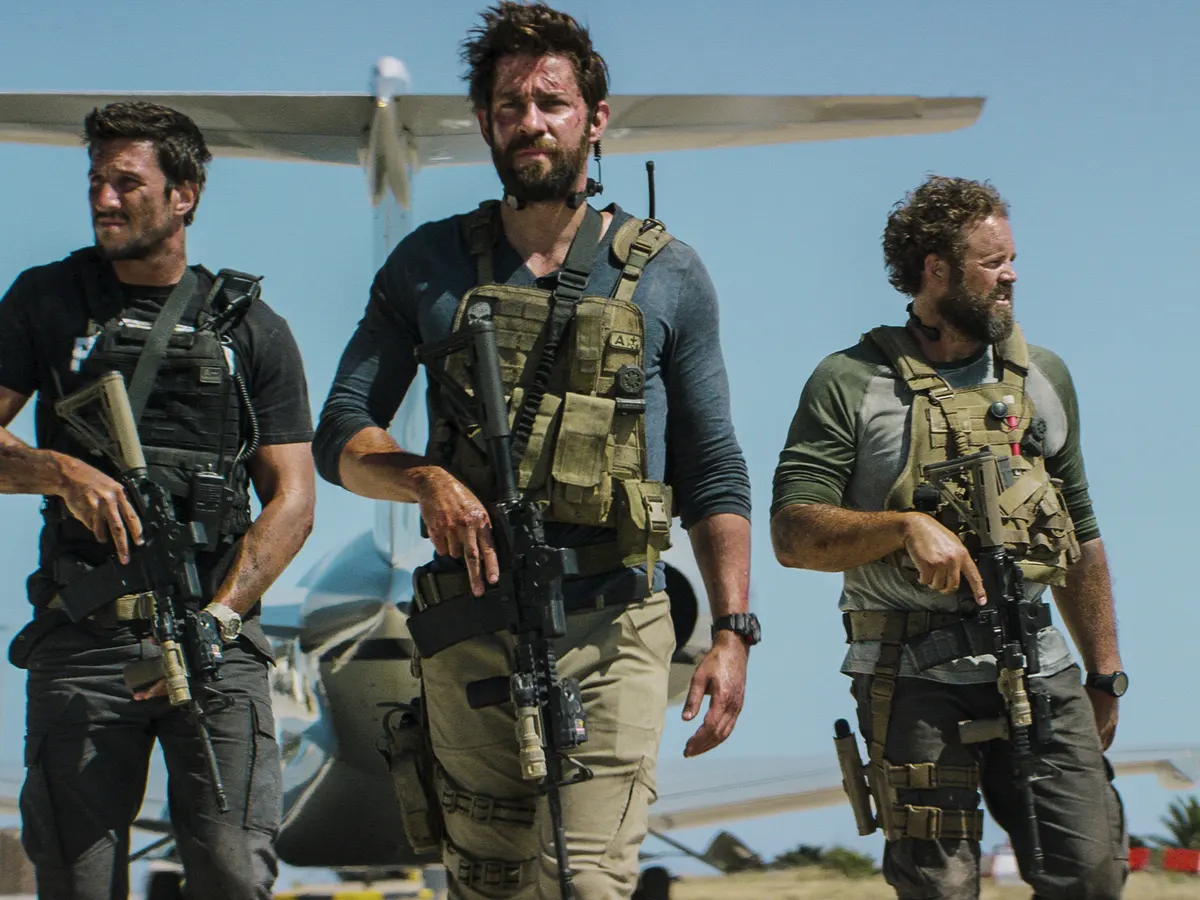Can you describe the interplay of emotions and body language exhibited by the individuals? Certainly. The central figure seems to embody leadership, with forward momentum and an unwavering gaze. The two flanking him reflect solidarity, with their postures mirroring his determination. This cohesive body language conveys a shared resolve, likely indicative of their training and the gravity of their task. 